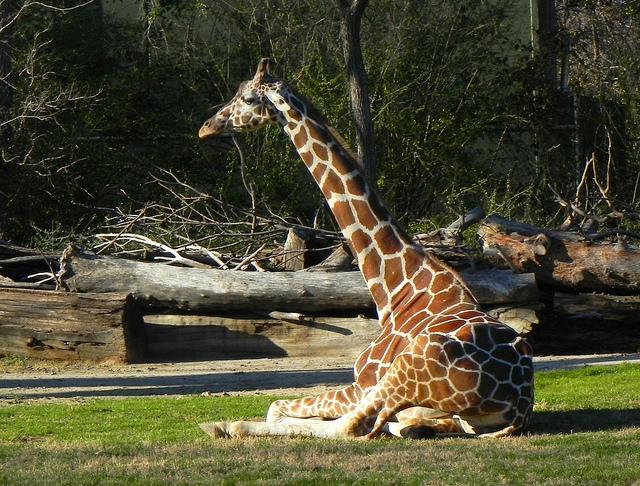What type of animal is in the photo?
Quick response, please. Giraffe. Is this animal standing?
Quick response, please. No. Did the giraffe just have an accident?
Give a very brief answer. No. 